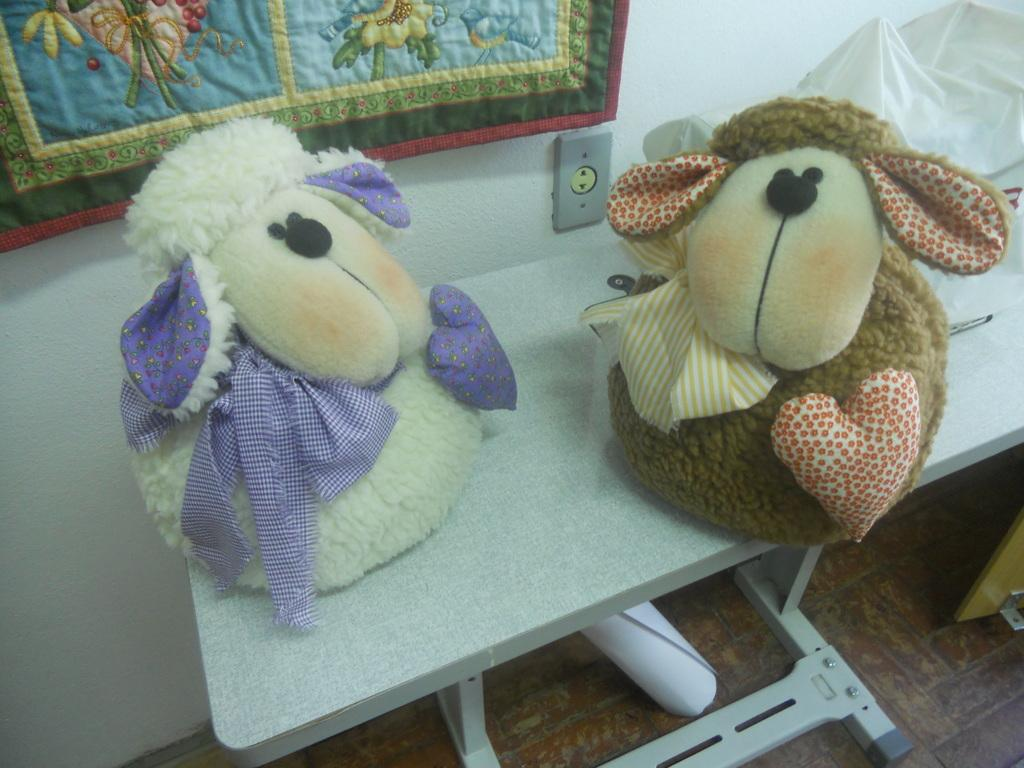How many toys can be seen in the image? There are two toys in the image. Where are the toys located? The toys are on a table in the image. What type of flooring is visible in the image? There is a wooden floor in the image. What electrical component is present in the image? A switchboard is present in the image. What type of fabric is visible in the image? A decorative cloth is visible in the image. Can you hear the band playing in the image? There is no band present in the image, so it is not possible to hear them playing. 